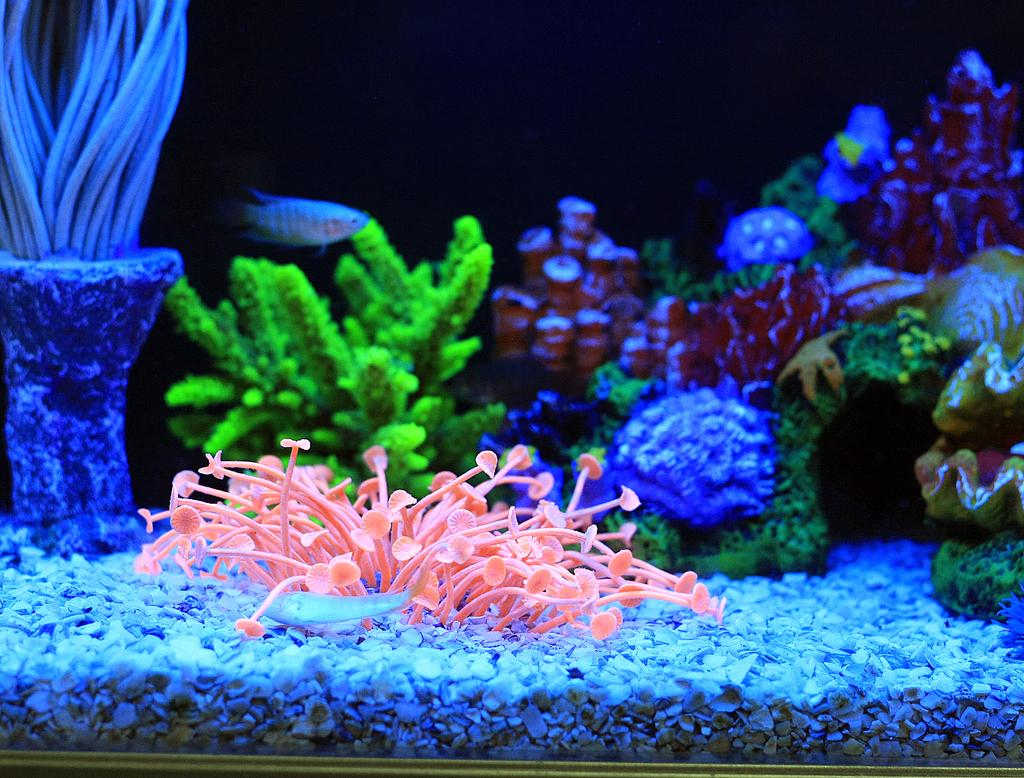What is the main subject of the image? The main subject of the image is an aquarium. What types of plants can be seen in the aquarium? The aquarium contains many aquatic plants. What other living creatures are present in the aquarium? There are fish in the aquarium. What type of material is present at the bottom of the aquarium? The aquarium contains stones. What is the color of the background in the image? The background of the image is black. How many bikes are parked next to the aquarium in the image? There are no bikes present in the image; it only features an aquarium. What type of dolls are floating in the aquarium? There are no dolls present in the image; it only features an aquarium with fish and aquatic plants. 